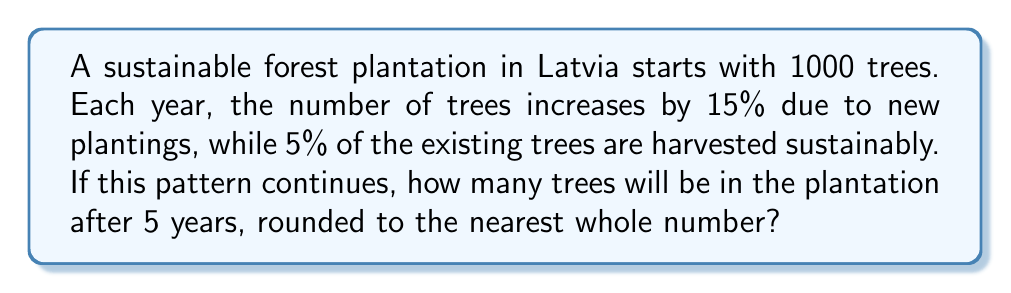Teach me how to tackle this problem. Let's approach this step-by-step:

1) The growth rate can be modeled as a geometric progression with a common ratio.

2) Each year, the number of trees increases by 15% but decreases by 5%.
   The net growth rate is: $1 + 0.15 - 0.05 = 1.10$ or 110%

3) Let's define our geometric sequence:
   $a_n = a_1 \cdot r^{n-1}$
   Where $a_1 = 1000$ (initial number of trees)
   $r = 1.10$ (common ratio)
   $n = 5$ (number of years)

4) Plugging into the formula:
   $a_5 = 1000 \cdot (1.10)^{5-1}$

5) Calculate:
   $a_5 = 1000 \cdot (1.10)^4$
   $a_5 = 1000 \cdot 1.4641$
   $a_5 = 1464.1$

6) Rounding to the nearest whole number:
   $a_5 \approx 1464$ trees
Answer: 1464 trees 